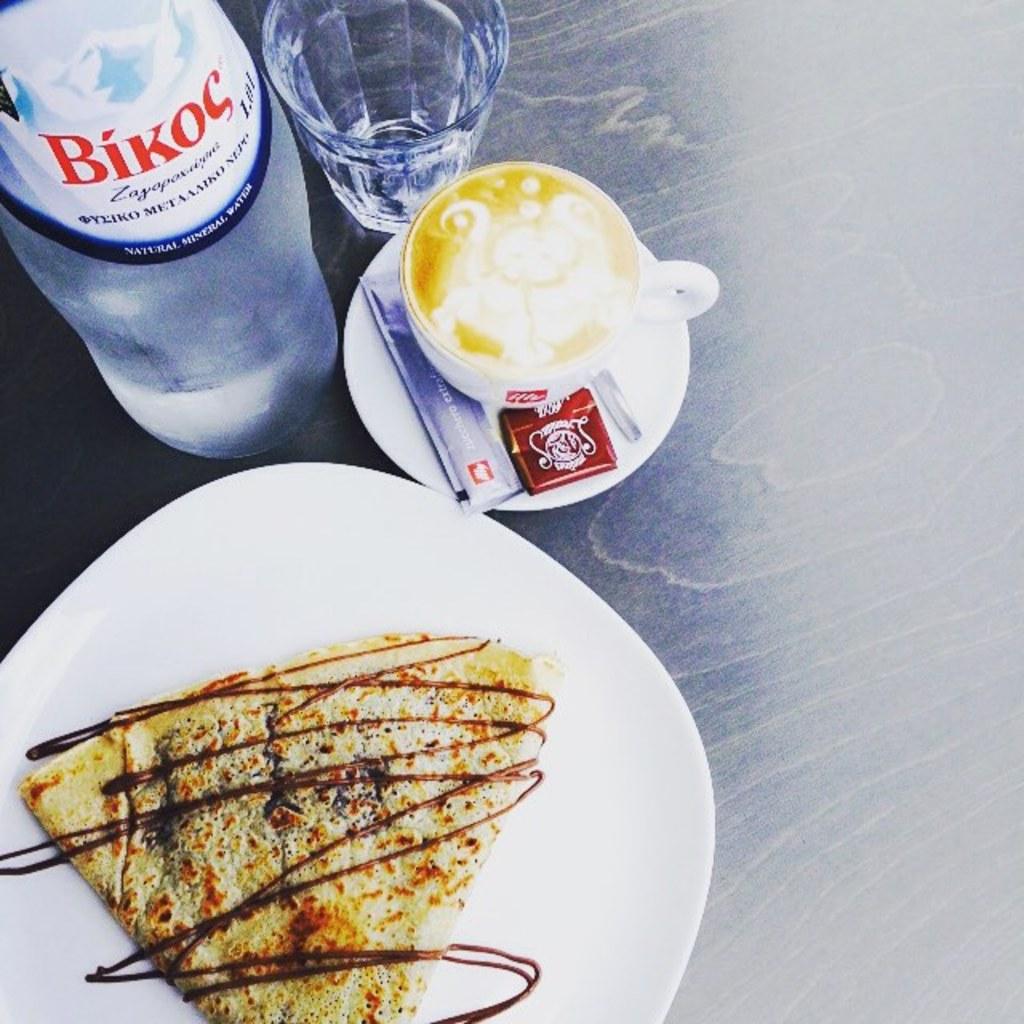What kind of water is it?
Provide a succinct answer. Bikoc. Which brand use?
Make the answer very short. Bikoc. 